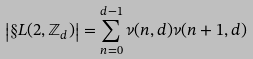Convert formula to latex. <formula><loc_0><loc_0><loc_500><loc_500>\left | \S L ( 2 , \mathbb { Z } _ { d } ) \right | = \sum _ { n = 0 } ^ { d - 1 } \nu ( n , d ) \nu ( n + 1 , d )</formula> 